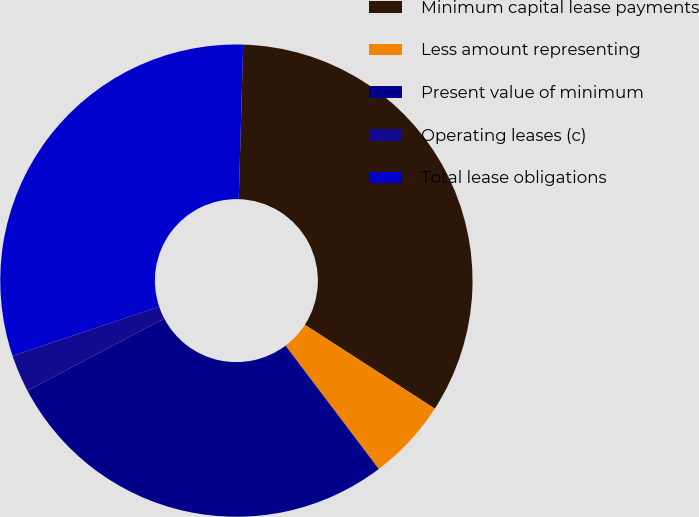Convert chart. <chart><loc_0><loc_0><loc_500><loc_500><pie_chart><fcel>Minimum capital lease payments<fcel>Less amount representing<fcel>Present value of minimum<fcel>Operating leases (c)<fcel>Total lease obligations<nl><fcel>33.66%<fcel>5.58%<fcel>27.59%<fcel>2.55%<fcel>30.62%<nl></chart> 